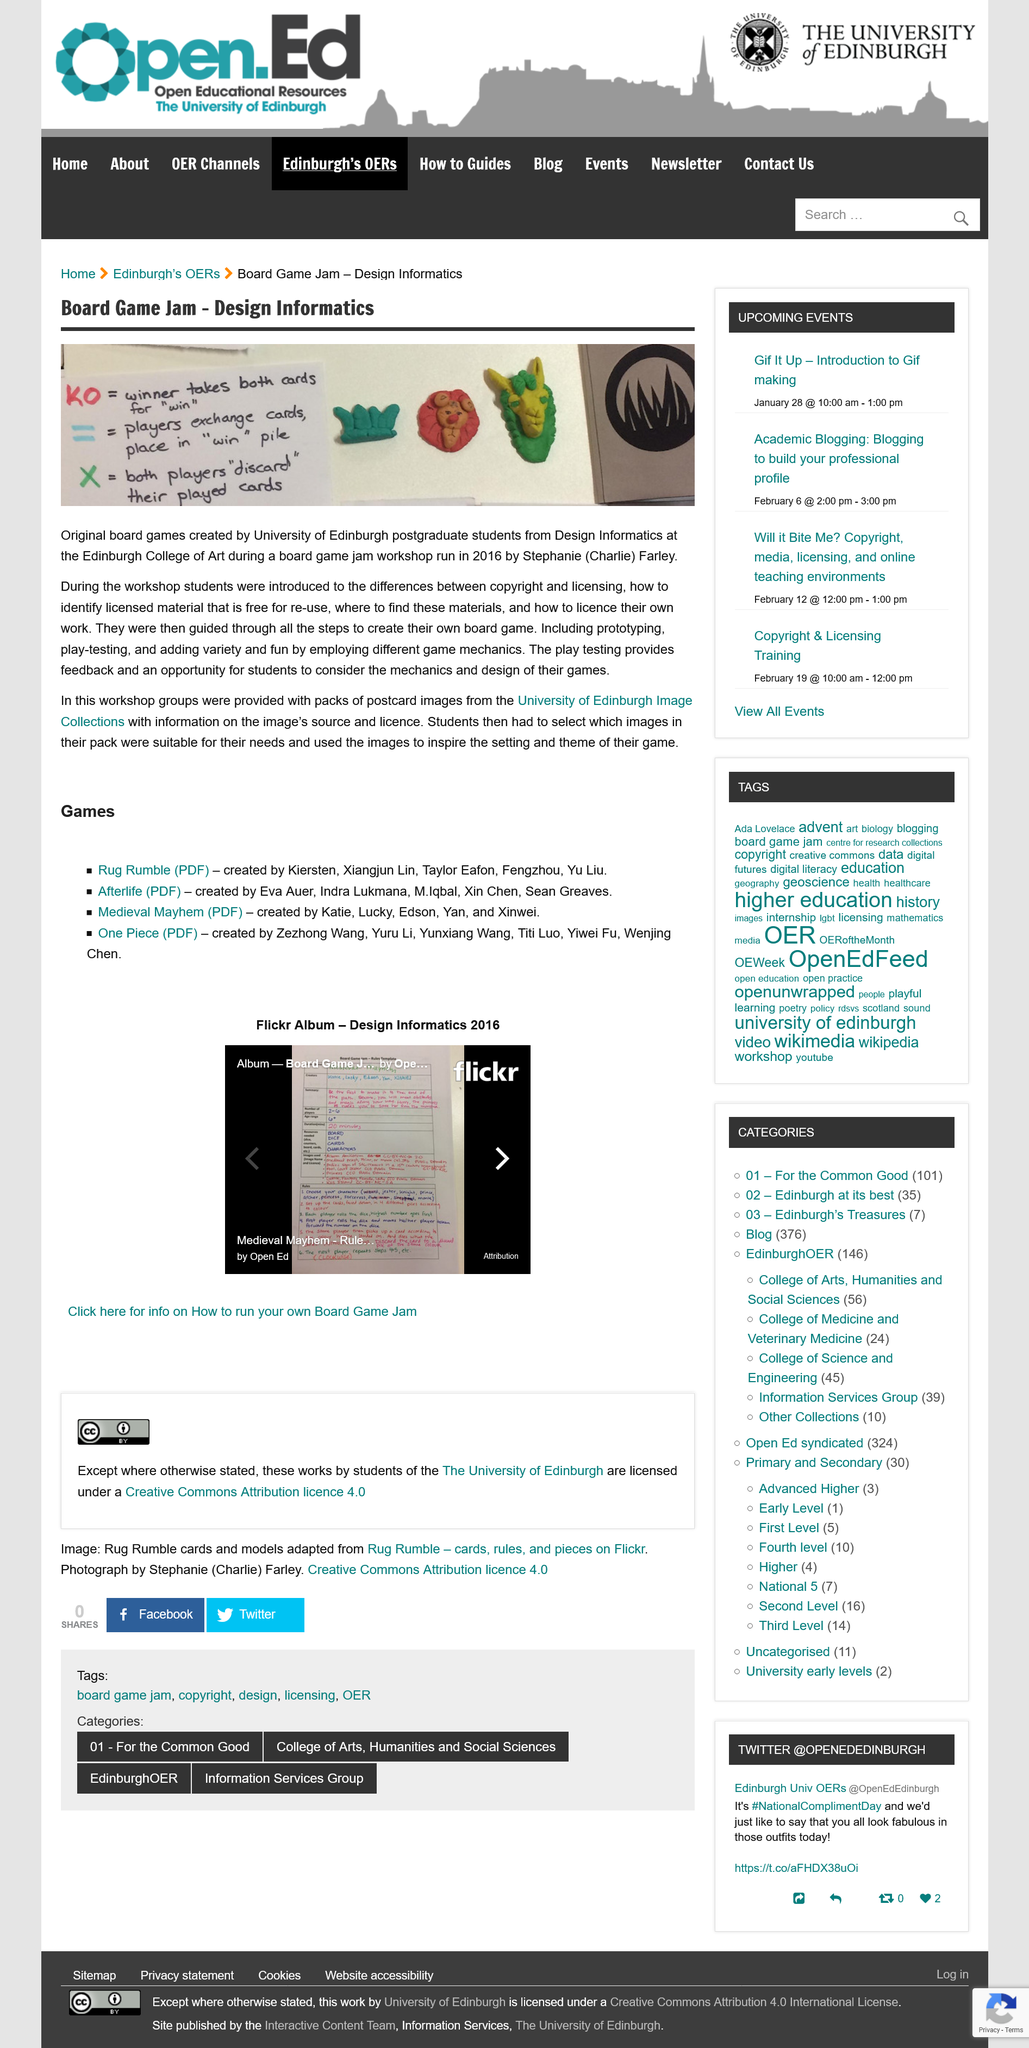Identify some key points in this picture. During the workshop, the students were introduced to the difference between copyright and licensing. Playtesting provides valuable feedback and offers students the opportunity to reflect on the mechanics and design of their games. Participants in the workshop were given packs of postcard images from the University of Edinburgh Image Collections as a resource for their group work. 